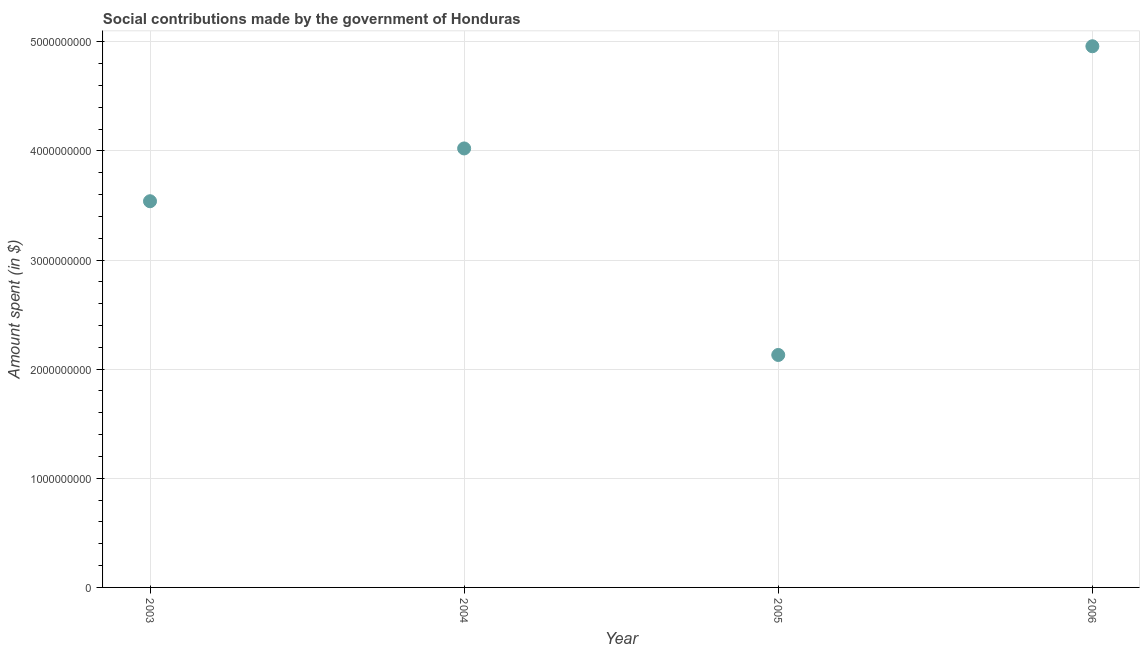What is the amount spent in making social contributions in 2005?
Your answer should be compact. 2.13e+09. Across all years, what is the maximum amount spent in making social contributions?
Provide a short and direct response. 4.96e+09. Across all years, what is the minimum amount spent in making social contributions?
Provide a short and direct response. 2.13e+09. In which year was the amount spent in making social contributions maximum?
Make the answer very short. 2006. What is the sum of the amount spent in making social contributions?
Ensure brevity in your answer.  1.46e+1. What is the difference between the amount spent in making social contributions in 2004 and 2006?
Offer a terse response. -9.36e+08. What is the average amount spent in making social contributions per year?
Offer a terse response. 3.66e+09. What is the median amount spent in making social contributions?
Provide a short and direct response. 3.78e+09. In how many years, is the amount spent in making social contributions greater than 4000000000 $?
Ensure brevity in your answer.  2. Do a majority of the years between 2006 and 2004 (inclusive) have amount spent in making social contributions greater than 1600000000 $?
Your answer should be compact. No. What is the ratio of the amount spent in making social contributions in 2005 to that in 2006?
Offer a terse response. 0.43. Is the amount spent in making social contributions in 2003 less than that in 2006?
Provide a succinct answer. Yes. Is the difference between the amount spent in making social contributions in 2004 and 2005 greater than the difference between any two years?
Make the answer very short. No. What is the difference between the highest and the second highest amount spent in making social contributions?
Your response must be concise. 9.36e+08. What is the difference between the highest and the lowest amount spent in making social contributions?
Give a very brief answer. 2.83e+09. In how many years, is the amount spent in making social contributions greater than the average amount spent in making social contributions taken over all years?
Keep it short and to the point. 2. How many dotlines are there?
Keep it short and to the point. 1. Does the graph contain any zero values?
Offer a terse response. No. What is the title of the graph?
Give a very brief answer. Social contributions made by the government of Honduras. What is the label or title of the Y-axis?
Offer a terse response. Amount spent (in $). What is the Amount spent (in $) in 2003?
Provide a short and direct response. 3.54e+09. What is the Amount spent (in $) in 2004?
Keep it short and to the point. 4.02e+09. What is the Amount spent (in $) in 2005?
Offer a terse response. 2.13e+09. What is the Amount spent (in $) in 2006?
Offer a very short reply. 4.96e+09. What is the difference between the Amount spent (in $) in 2003 and 2004?
Offer a terse response. -4.84e+08. What is the difference between the Amount spent (in $) in 2003 and 2005?
Provide a succinct answer. 1.41e+09. What is the difference between the Amount spent (in $) in 2003 and 2006?
Keep it short and to the point. -1.42e+09. What is the difference between the Amount spent (in $) in 2004 and 2005?
Your answer should be compact. 1.89e+09. What is the difference between the Amount spent (in $) in 2004 and 2006?
Your answer should be very brief. -9.36e+08. What is the difference between the Amount spent (in $) in 2005 and 2006?
Your answer should be very brief. -2.83e+09. What is the ratio of the Amount spent (in $) in 2003 to that in 2004?
Keep it short and to the point. 0.88. What is the ratio of the Amount spent (in $) in 2003 to that in 2005?
Your answer should be compact. 1.66. What is the ratio of the Amount spent (in $) in 2003 to that in 2006?
Your response must be concise. 0.71. What is the ratio of the Amount spent (in $) in 2004 to that in 2005?
Provide a succinct answer. 1.89. What is the ratio of the Amount spent (in $) in 2004 to that in 2006?
Your answer should be very brief. 0.81. What is the ratio of the Amount spent (in $) in 2005 to that in 2006?
Offer a very short reply. 0.43. 